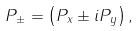Convert formula to latex. <formula><loc_0><loc_0><loc_500><loc_500>P _ { \pm } = \left ( P _ { x } \pm i P _ { y } \right ) ,</formula> 